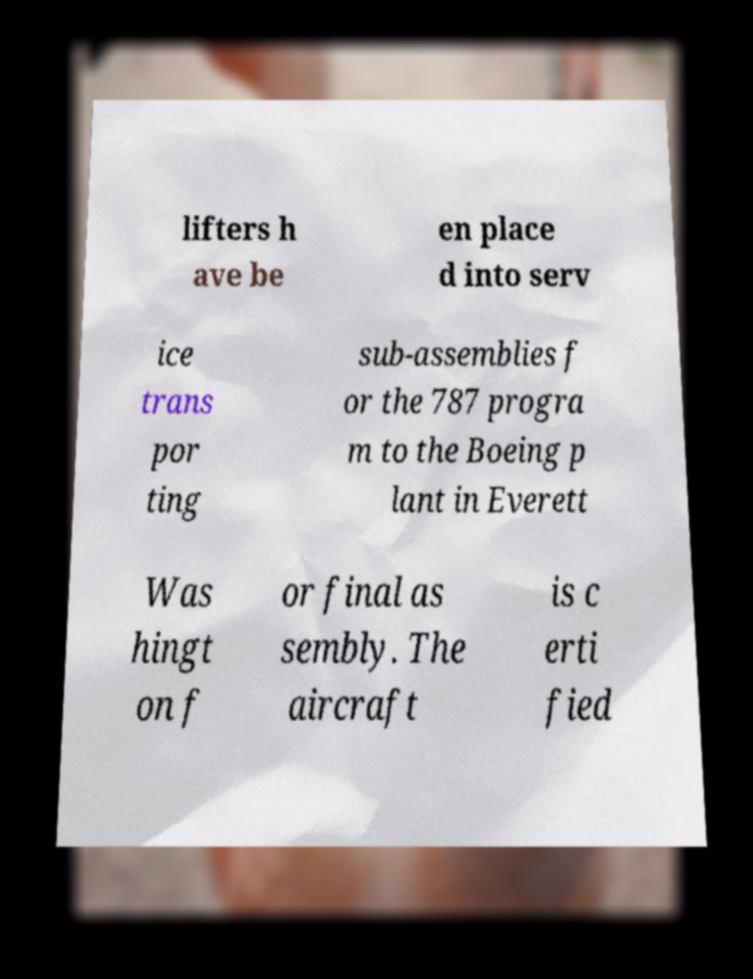Can you accurately transcribe the text from the provided image for me? lifters h ave be en place d into serv ice trans por ting sub-assemblies f or the 787 progra m to the Boeing p lant in Everett Was hingt on f or final as sembly. The aircraft is c erti fied 